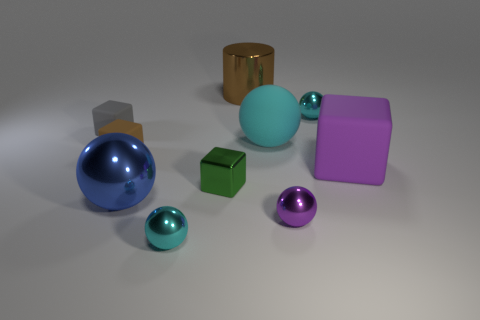How many cyan matte objects are there?
Provide a short and direct response. 1. There is a matte ball behind the small green object; what size is it?
Your answer should be compact. Large. Are there the same number of gray rubber things in front of the tiny purple thing and green shiny things?
Your answer should be very brief. No. Are there any other metal things of the same shape as the large brown shiny thing?
Your response must be concise. No. What shape is the tiny object that is both behind the big cyan matte thing and to the right of the big metallic sphere?
Offer a terse response. Sphere. Are the gray block and the cyan sphere in front of the purple cube made of the same material?
Ensure brevity in your answer.  No. There is a small purple thing; are there any tiny cyan balls in front of it?
Make the answer very short. Yes. How many objects are small brown rubber cubes or small cyan objects behind the large purple object?
Give a very brief answer. 2. The metallic object to the right of the purple object in front of the big matte cube is what color?
Your response must be concise. Cyan. What number of other things are there of the same material as the tiny gray cube
Ensure brevity in your answer.  3. 